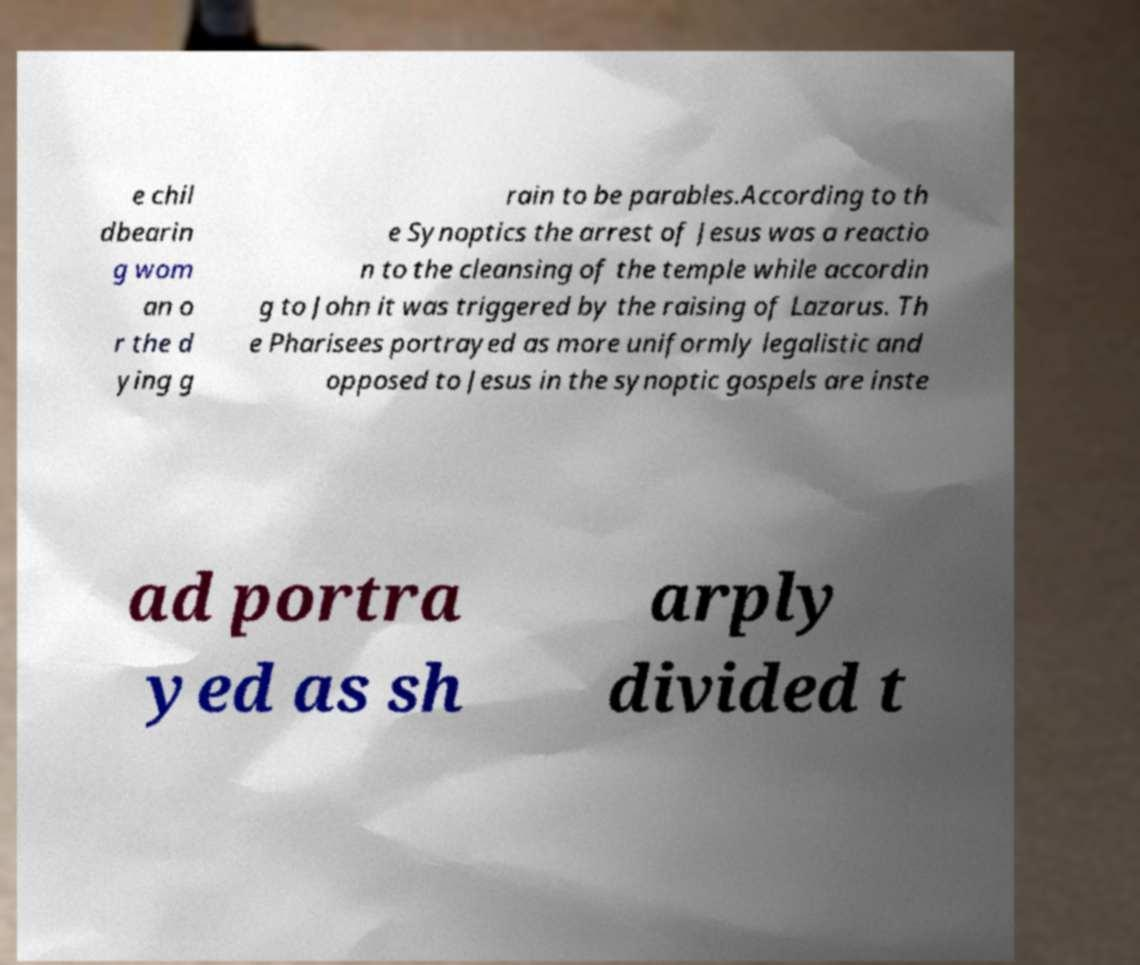I need the written content from this picture converted into text. Can you do that? e chil dbearin g wom an o r the d ying g rain to be parables.According to th e Synoptics the arrest of Jesus was a reactio n to the cleansing of the temple while accordin g to John it was triggered by the raising of Lazarus. Th e Pharisees portrayed as more uniformly legalistic and opposed to Jesus in the synoptic gospels are inste ad portra yed as sh arply divided t 